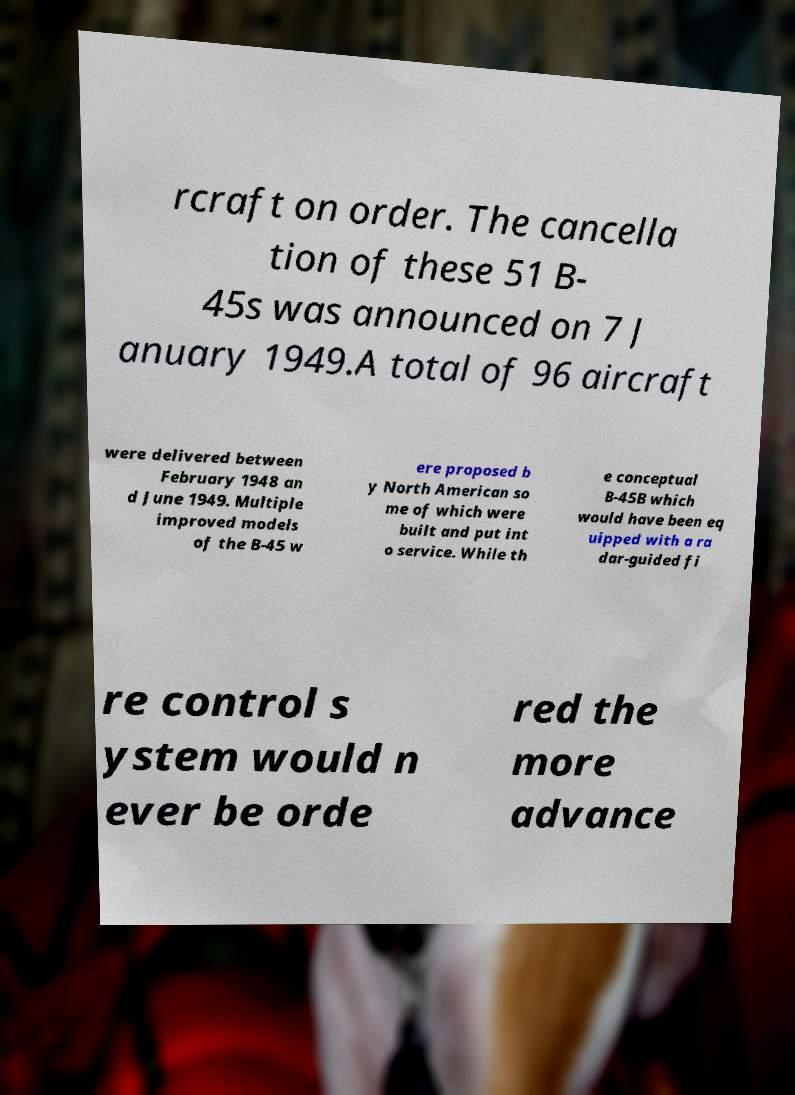Could you extract and type out the text from this image? rcraft on order. The cancella tion of these 51 B- 45s was announced on 7 J anuary 1949.A total of 96 aircraft were delivered between February 1948 an d June 1949. Multiple improved models of the B-45 w ere proposed b y North American so me of which were built and put int o service. While th e conceptual B-45B which would have been eq uipped with a ra dar-guided fi re control s ystem would n ever be orde red the more advance 